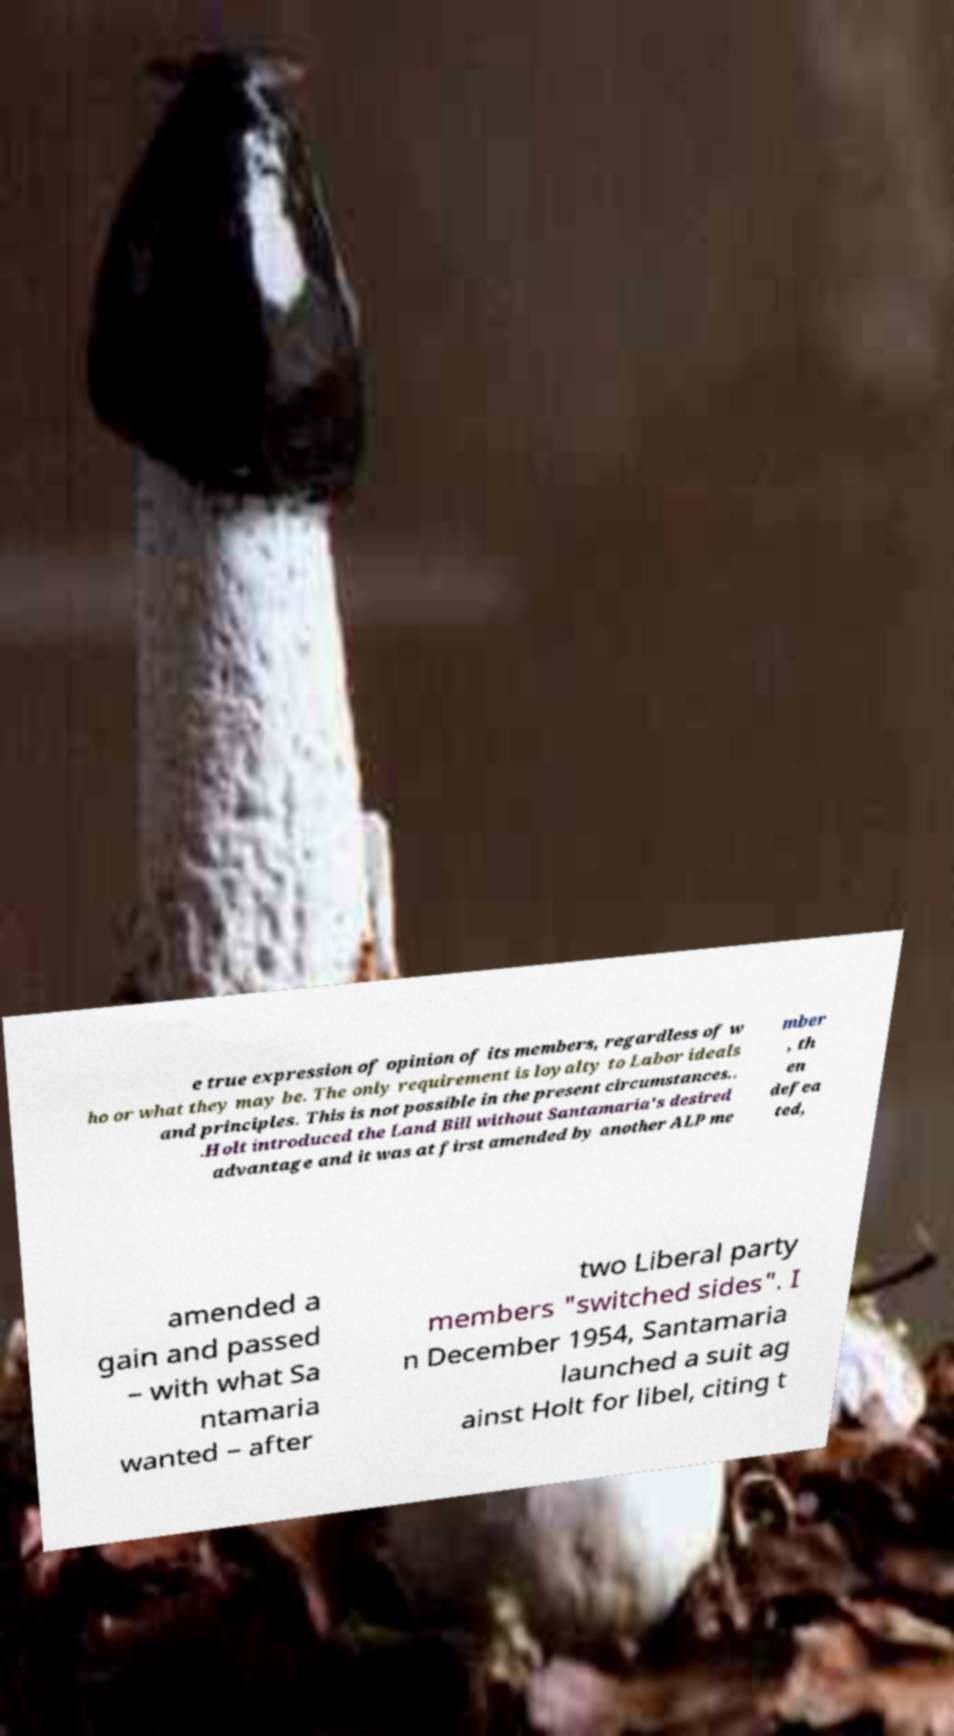Could you assist in decoding the text presented in this image and type it out clearly? e true expression of opinion of its members, regardless of w ho or what they may be. The only requirement is loyalty to Labor ideals and principles. This is not possible in the present circumstances.. .Holt introduced the Land Bill without Santamaria's desired advantage and it was at first amended by another ALP me mber , th en defea ted, amended a gain and passed – with what Sa ntamaria wanted – after two Liberal party members "switched sides". I n December 1954, Santamaria launched a suit ag ainst Holt for libel, citing t 